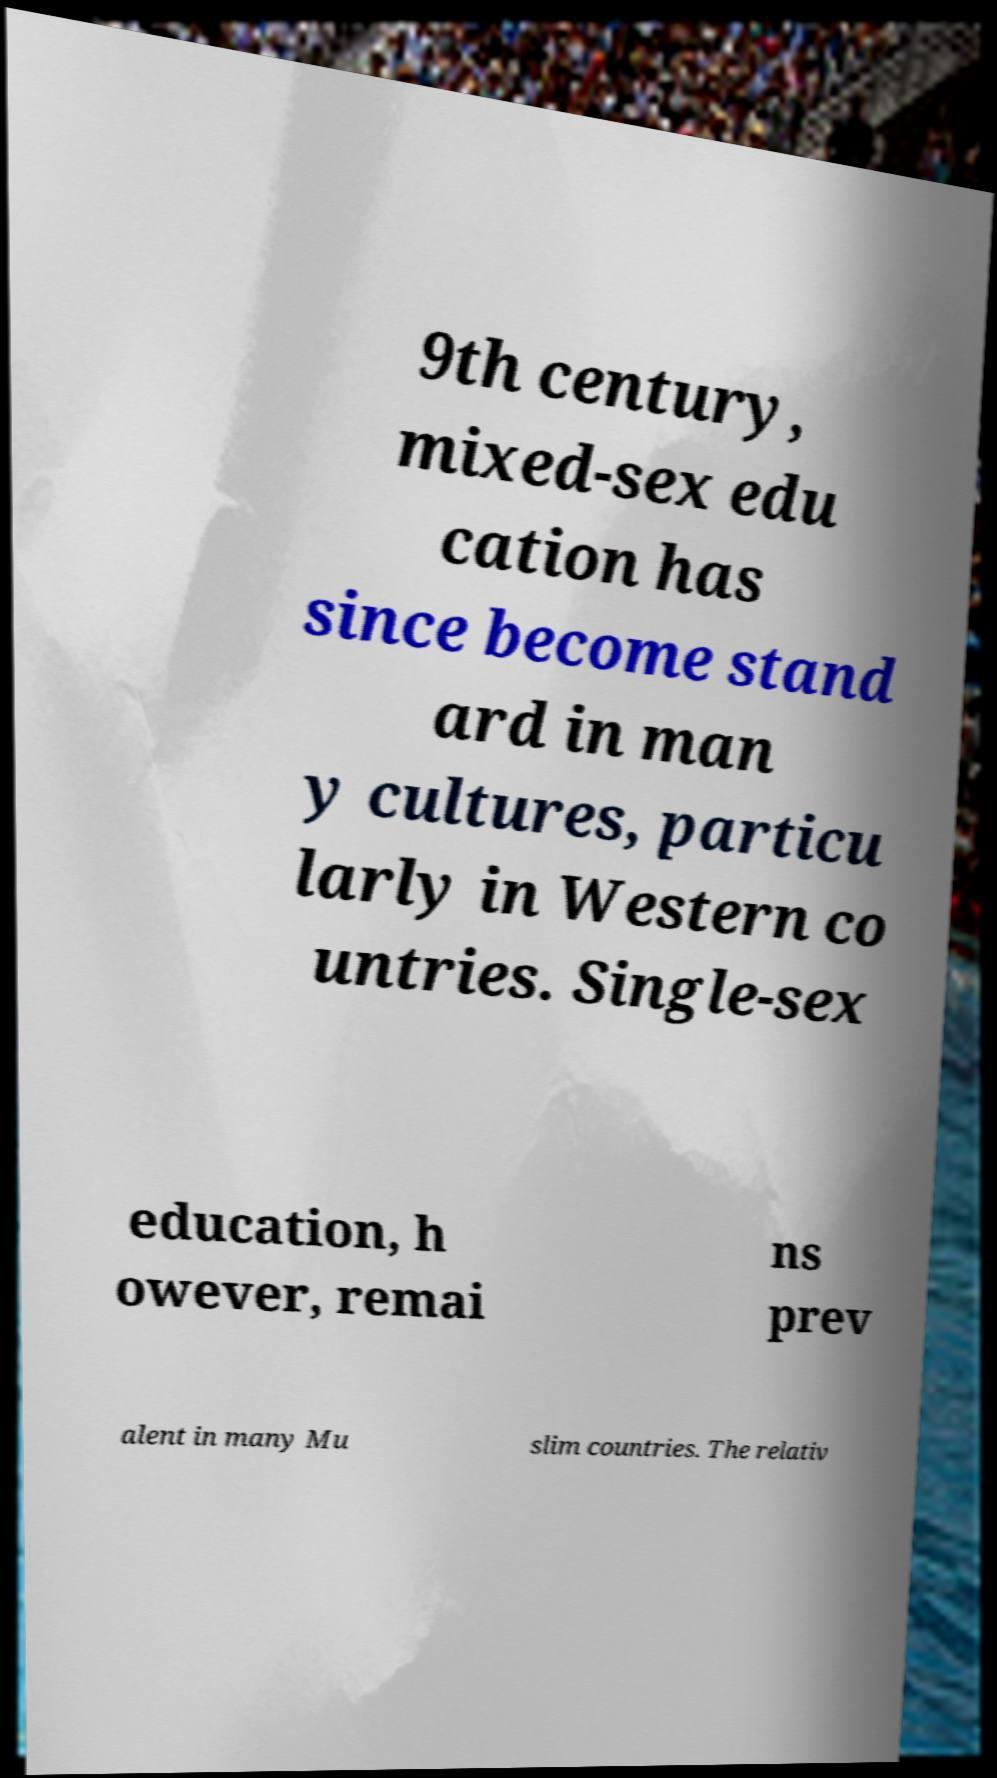Please read and relay the text visible in this image. What does it say? 9th century, mixed-sex edu cation has since become stand ard in man y cultures, particu larly in Western co untries. Single-sex education, h owever, remai ns prev alent in many Mu slim countries. The relativ 